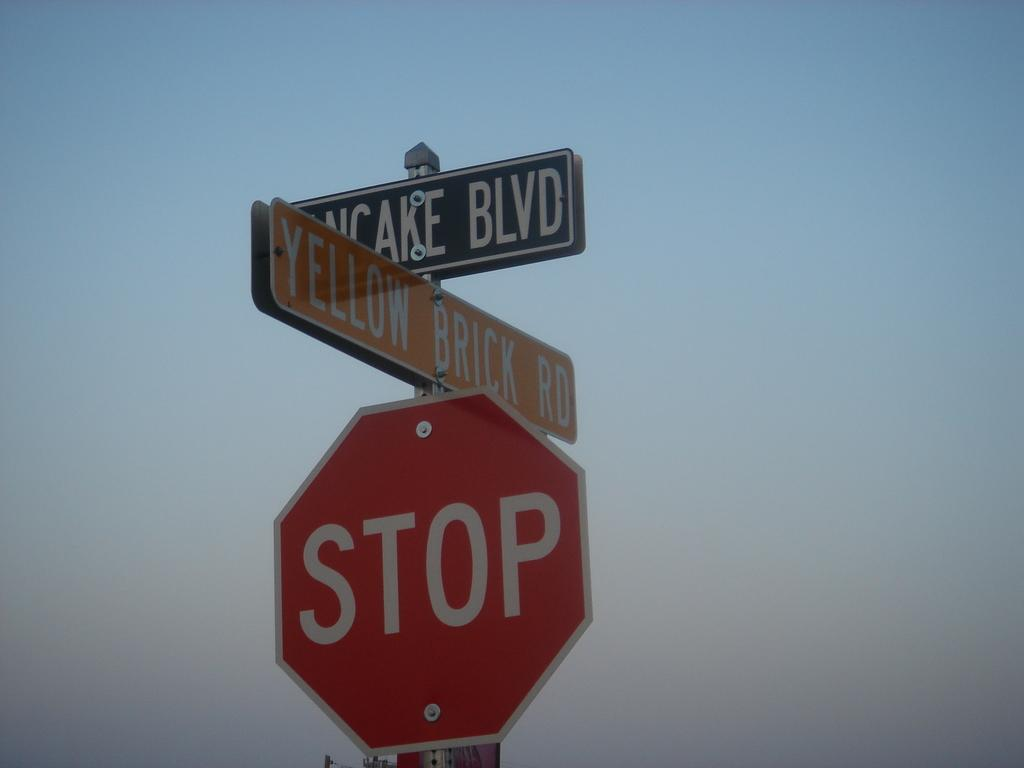<image>
Relay a brief, clear account of the picture shown. At the intersection of Pancake Blvd and Yellow Brick Road is a stop sign. 